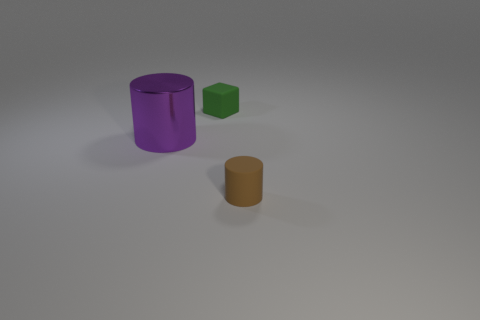There is another object that is the same shape as the large purple metallic thing; what material is it?
Offer a terse response. Rubber. What size is the matte object that is in front of the cylinder left of the small rubber thing that is left of the brown matte cylinder?
Provide a succinct answer. Small. Do the brown thing and the purple thing have the same size?
Keep it short and to the point. No. What is the tiny thing that is behind the small matte object on the right side of the green rubber cube made of?
Provide a short and direct response. Rubber. There is a tiny rubber object that is in front of the big purple metallic cylinder; does it have the same shape as the object that is to the left of the tiny green matte cube?
Offer a very short reply. Yes. Are there an equal number of cylinders on the left side of the brown rubber cylinder and brown matte cylinders?
Offer a very short reply. Yes. There is a rubber object behind the purple metallic cylinder; is there a large purple cylinder that is behind it?
Give a very brief answer. No. Is there any other thing that has the same color as the tiny rubber cylinder?
Your answer should be compact. No. Do the small thing to the left of the tiny brown cylinder and the large cylinder have the same material?
Offer a terse response. No. Is the number of small matte cylinders that are right of the small brown cylinder the same as the number of large purple cylinders that are behind the big shiny cylinder?
Your response must be concise. Yes. 